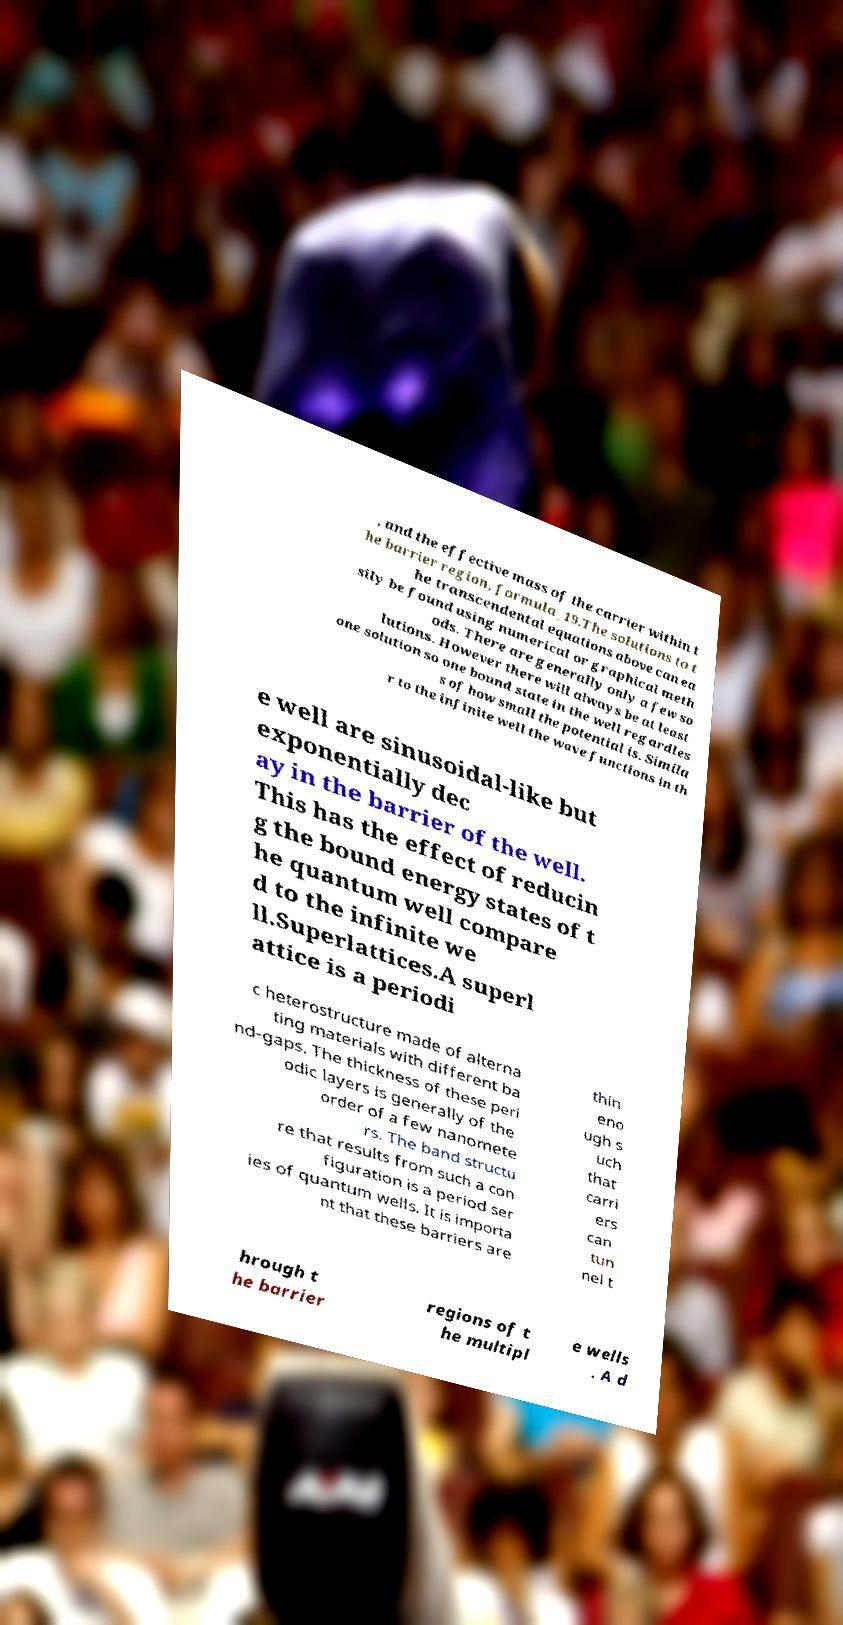Please read and relay the text visible in this image. What does it say? , and the effective mass of the carrier within t he barrier region, formula_19.The solutions to t he transcendental equations above can ea sily be found using numerical or graphical meth ods. There are generally only a few so lutions. However there will always be at least one solution so one bound state in the well regardles s of how small the potential is. Simila r to the infinite well the wave functions in th e well are sinusoidal-like but exponentially dec ay in the barrier of the well. This has the effect of reducin g the bound energy states of t he quantum well compare d to the infinite we ll.Superlattices.A superl attice is a periodi c heterostructure made of alterna ting materials with different ba nd-gaps. The thickness of these peri odic layers is generally of the order of a few nanomete rs. The band structu re that results from such a con figuration is a period ser ies of quantum wells. It is importa nt that these barriers are thin eno ugh s uch that carri ers can tun nel t hrough t he barrier regions of t he multipl e wells . A d 